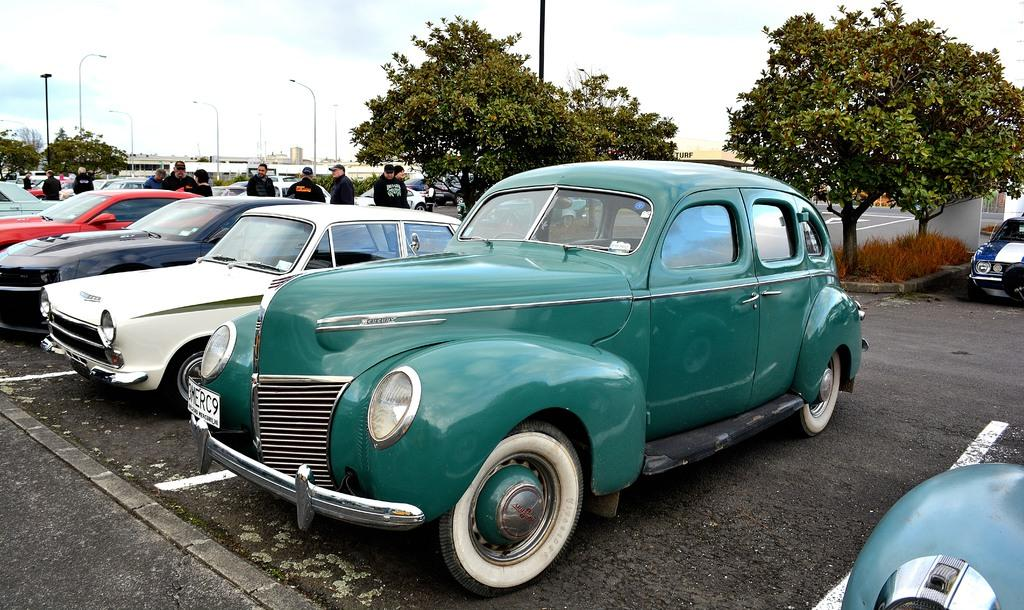What types of vehicles can be seen in the image? There are vehicles in the image, but the specific types are not mentioned. What are the people on the road doing in the image? The people standing on the road are visible, but their actions are not described. What can be seen in the background of the image? In the background of the image, there are pole lights, trees, the sky, buildings, and other objects. Is there any poison visible in the image? There is no mention of poison in the image, so it cannot be determined if it is present. What type of tramp is shown in the image? There is no tramp present in the image. 